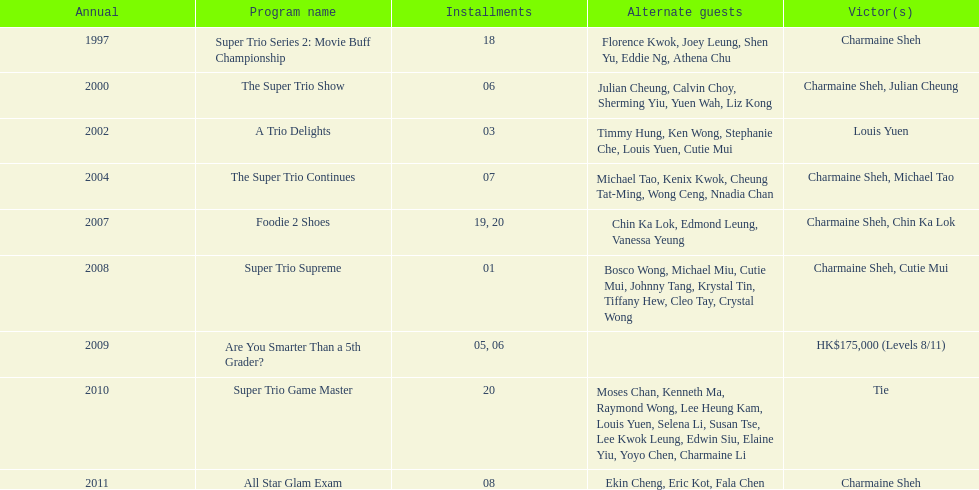Parse the table in full. {'header': ['Annual', 'Program name', 'Installments', 'Alternate guests', 'Victor(s)'], 'rows': [['1997', 'Super Trio Series 2: Movie Buff Championship', '18', 'Florence Kwok, Joey Leung, Shen Yu, Eddie Ng, Athena Chu', 'Charmaine Sheh'], ['2000', 'The Super Trio Show', '06', 'Julian Cheung, Calvin Choy, Sherming Yiu, Yuen Wah, Liz Kong', 'Charmaine Sheh, Julian Cheung'], ['2002', 'A Trio Delights', '03', 'Timmy Hung, Ken Wong, Stephanie Che, Louis Yuen, Cutie Mui', 'Louis Yuen'], ['2004', 'The Super Trio Continues', '07', 'Michael Tao, Kenix Kwok, Cheung Tat-Ming, Wong Ceng, Nnadia Chan', 'Charmaine Sheh, Michael Tao'], ['2007', 'Foodie 2 Shoes', '19, 20', 'Chin Ka Lok, Edmond Leung, Vanessa Yeung', 'Charmaine Sheh, Chin Ka Lok'], ['2008', 'Super Trio Supreme', '01', 'Bosco Wong, Michael Miu, Cutie Mui, Johnny Tang, Krystal Tin, Tiffany Hew, Cleo Tay, Crystal Wong', 'Charmaine Sheh, Cutie Mui'], ['2009', 'Are You Smarter Than a 5th Grader?', '05, 06', '', 'HK$175,000 (Levels 8/11)'], ['2010', 'Super Trio Game Master', '20', 'Moses Chan, Kenneth Ma, Raymond Wong, Lee Heung Kam, Louis Yuen, Selena Li, Susan Tse, Lee Kwok Leung, Edwin Siu, Elaine Yiu, Yoyo Chen, Charmaine Li', 'Tie'], ['2011', 'All Star Glam Exam', '08', 'Ekin Cheng, Eric Kot, Fala Chen', 'Charmaine Sheh']]} What is the number of tv shows that charmaine sheh has appeared on? 9. 